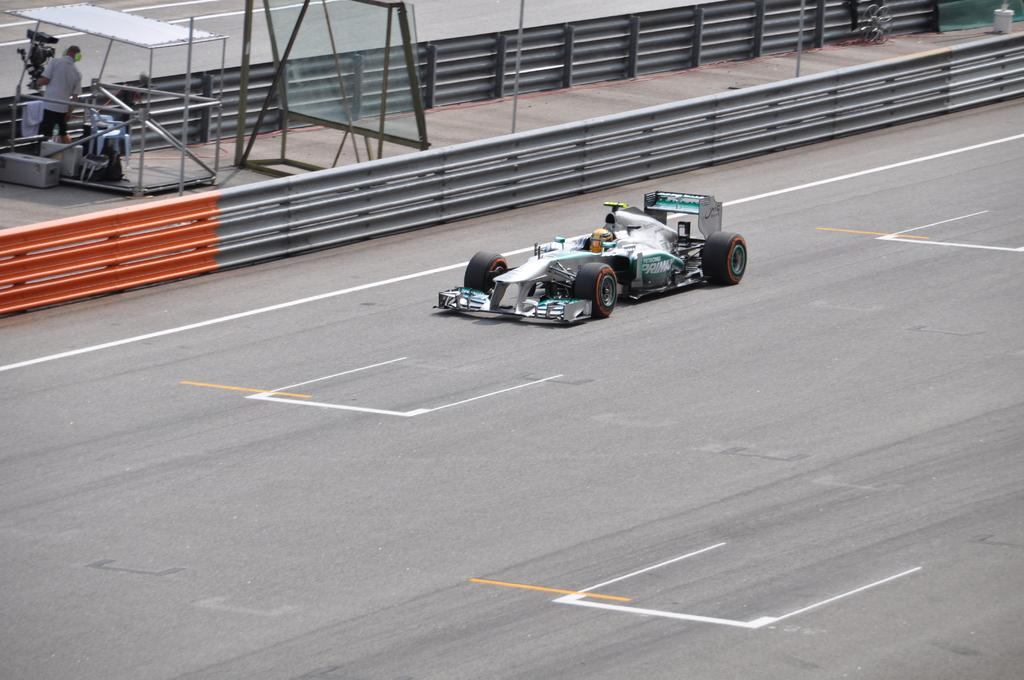Where was the image taken? The image was taken outside. Can you describe the person in the top left corner of the image? There is a person in the top left corner of the image. What is the small vehicle in the middle of the image? There is a small vehicle in the middle of the image. Who is inside the vehicle? There is a person sitting inside the vehicle. What type of ghost can be seen in the image? There are no ghosts present in the image. Is there a fire visible in the image? There is no fire visible in the image. 